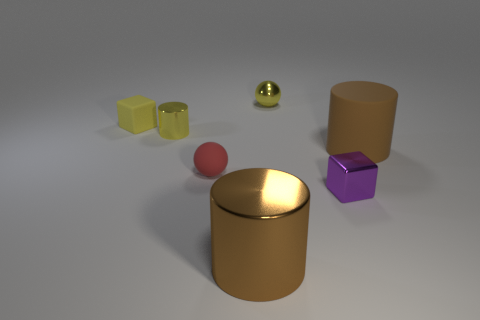What number of objects are either purple metal cubes or blue cylinders?
Provide a short and direct response. 1. How many yellow cubes have the same material as the purple block?
Ensure brevity in your answer.  0. Is the number of tiny yellow shiny objects less than the number of tiny green blocks?
Provide a succinct answer. No. Are the yellow object that is behind the yellow rubber thing and the red object made of the same material?
Give a very brief answer. No. How many cubes are red rubber objects or tiny metal objects?
Keep it short and to the point. 1. The matte thing that is in front of the yellow matte block and left of the purple metallic thing has what shape?
Offer a very short reply. Sphere. What color is the tiny matte object in front of the tiny yellow shiny thing in front of the block that is on the left side of the tiny yellow shiny cylinder?
Make the answer very short. Red. Are there fewer rubber cylinders that are left of the brown rubber object than small gray cylinders?
Your response must be concise. No. Is the shape of the small metallic thing behind the tiny yellow block the same as the brown object that is on the right side of the tiny purple cube?
Keep it short and to the point. No. How many things are either small cubes in front of the tiny red rubber sphere or purple objects?
Offer a terse response. 1. 